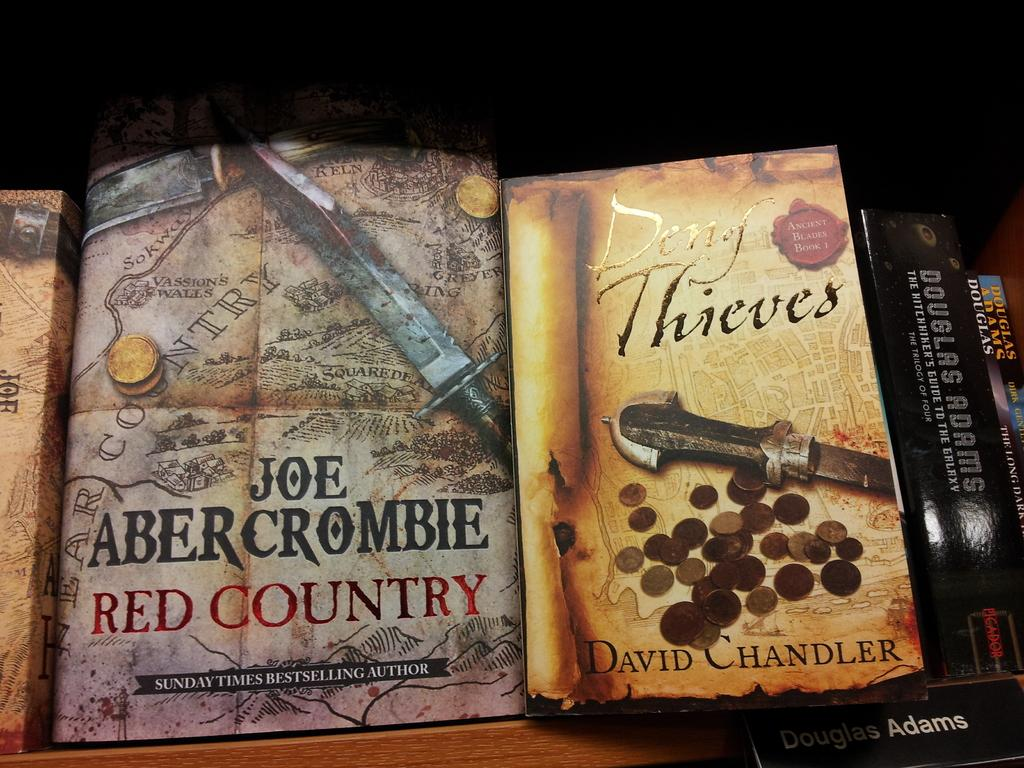<image>
Present a compact description of the photo's key features. various books that includes deny thieves and joe abercrombie 